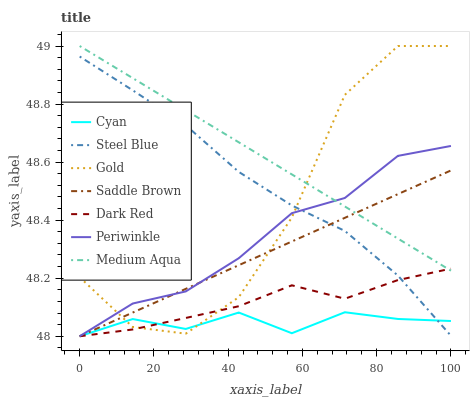Does Cyan have the minimum area under the curve?
Answer yes or no. Yes. Does Medium Aqua have the maximum area under the curve?
Answer yes or no. Yes. Does Gold have the minimum area under the curve?
Answer yes or no. No. Does Gold have the maximum area under the curve?
Answer yes or no. No. Is Medium Aqua the smoothest?
Answer yes or no. Yes. Is Gold the roughest?
Answer yes or no. Yes. Is Dark Red the smoothest?
Answer yes or no. No. Is Dark Red the roughest?
Answer yes or no. No. Does Dark Red have the lowest value?
Answer yes or no. Yes. Does Gold have the lowest value?
Answer yes or no. No. Does Gold have the highest value?
Answer yes or no. Yes. Does Dark Red have the highest value?
Answer yes or no. No. Is Steel Blue less than Medium Aqua?
Answer yes or no. Yes. Is Medium Aqua greater than Steel Blue?
Answer yes or no. Yes. Does Periwinkle intersect Medium Aqua?
Answer yes or no. Yes. Is Periwinkle less than Medium Aqua?
Answer yes or no. No. Is Periwinkle greater than Medium Aqua?
Answer yes or no. No. Does Steel Blue intersect Medium Aqua?
Answer yes or no. No. 